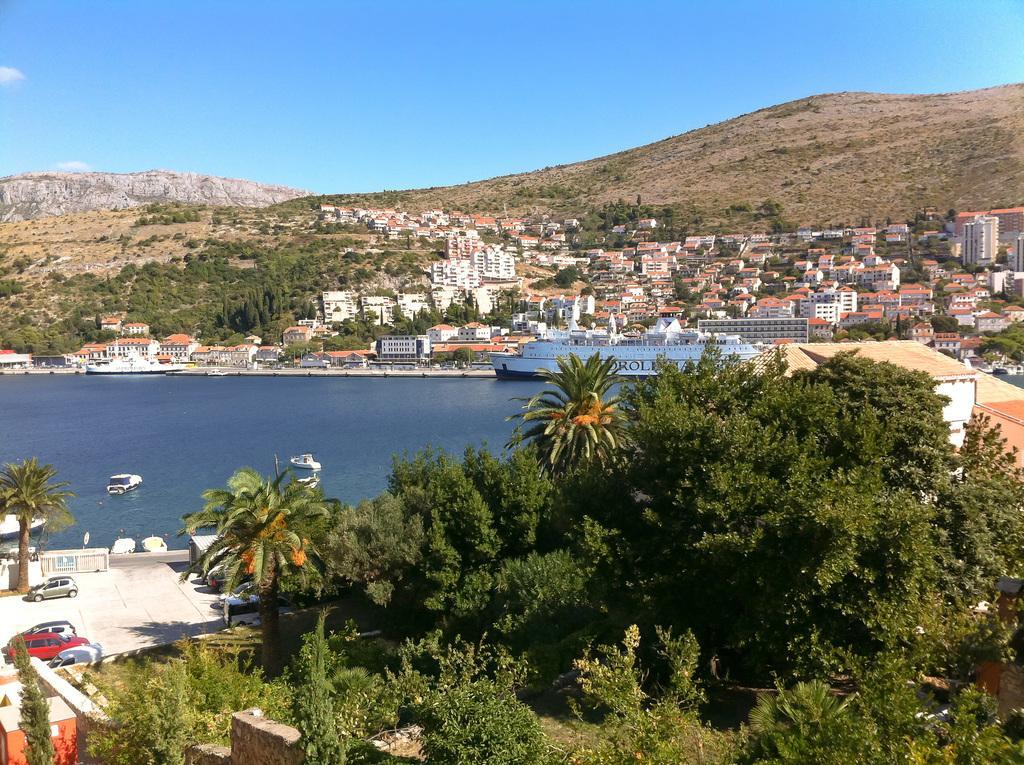Can you describe this image briefly? Here we can see a ship and boats on the water. There are plants, trees, vehicles, and buildings. In the background we can see mountain and sky. 